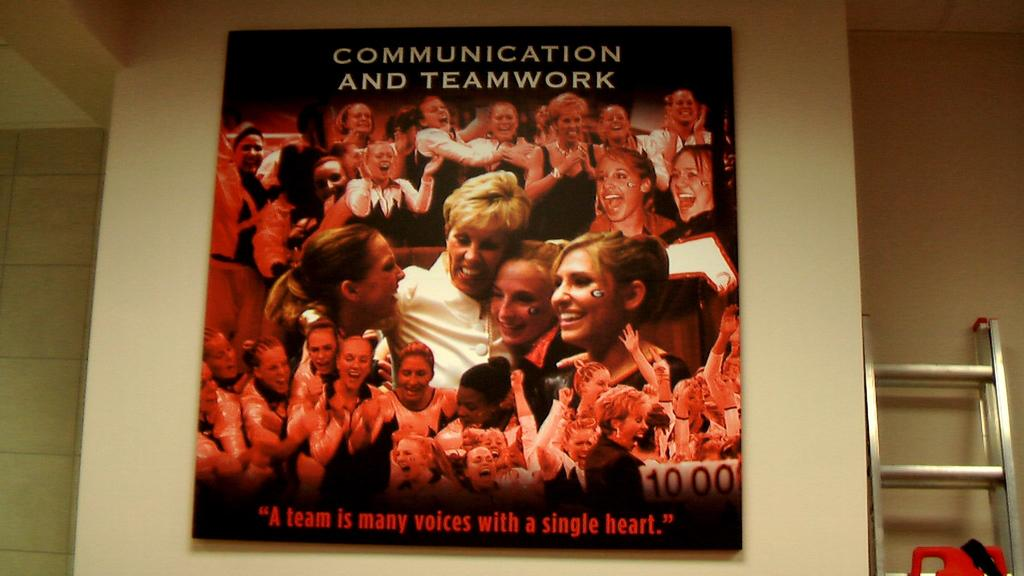<image>
Describe the image concisely. A poster with many people on it that says Communication and teamwork. 